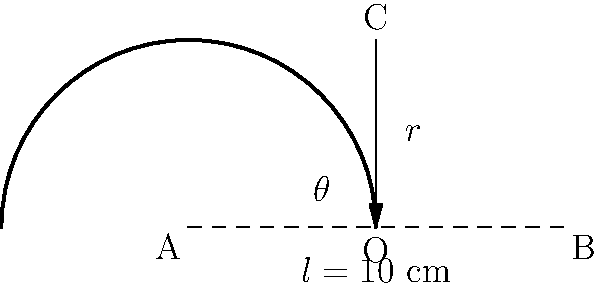As an art historian examining a rolled scroll, you need to estimate its curvature. The scroll forms an arc AB with a chord length of 10 cm. The perpendicular distance from the midpoint of the chord to the arc is 2.5 cm. Using trigonometric equations, calculate the radius of curvature of the scroll to the nearest 0.1 cm. Let's approach this step-by-step:

1) In the diagram, AB is the chord of length $l = 10$ cm, and O is the center of the circle.

2) The perpendicular distance from the midpoint of the chord to the arc (CO) is given as 2.5 cm.

3) Let $r$ be the radius of the circle and $\theta$ be the central angle in radians.

4) We can split the triangle AOC into two right triangles. In one of these right triangles:
   - The hypotenuse is $r$
   - Half of the chord length is $5$ cm
   - The height is $2.5$ cm

5) Using the Pythagorean theorem:
   $r^2 = 5^2 + (r - 2.5)^2$

6) Expanding this equation:
   $r^2 = 25 + r^2 - 5r + 6.25$

7) Simplifying:
   $5r = 31.25$

8) Solving for $r$:
   $r = 31.25 / 5 = 6.25$ cm

9) Rounding to the nearest 0.1 cm:
   $r \approx 6.3$ cm

Therefore, the radius of curvature of the scroll is approximately 6.3 cm.
Answer: 6.3 cm 